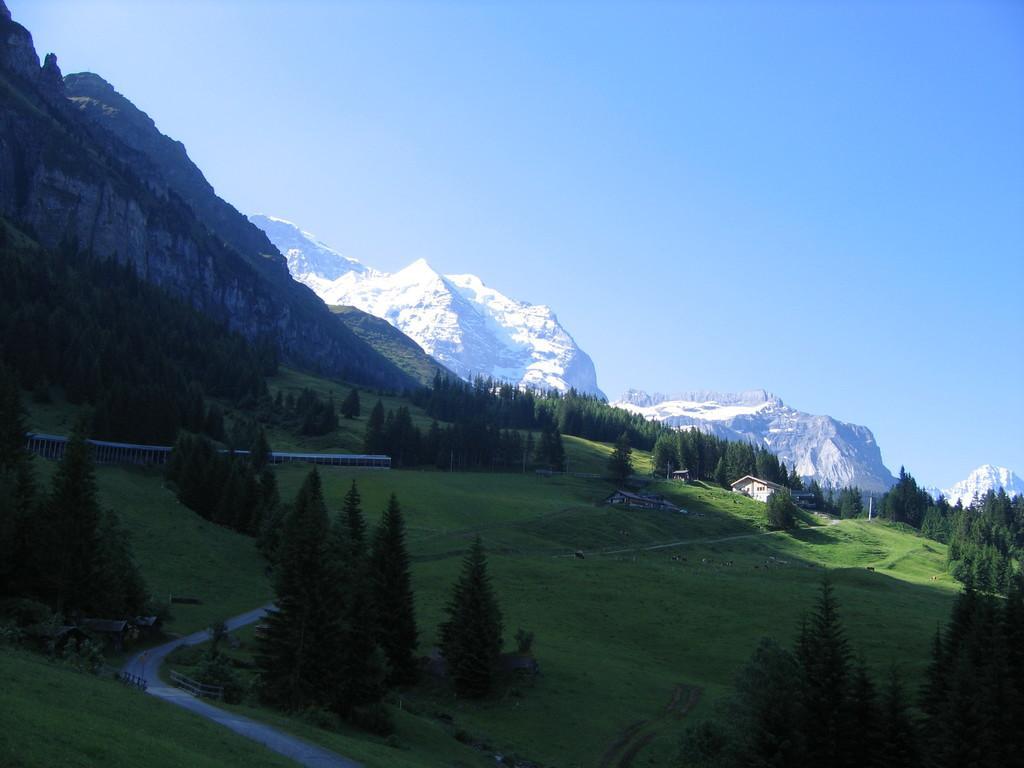In one or two sentences, can you explain what this image depicts? In this image I can see the road, some grass, few trees, a building which is cream in color and in the background I can see few mountains, some snow on the mountains and the sky. 